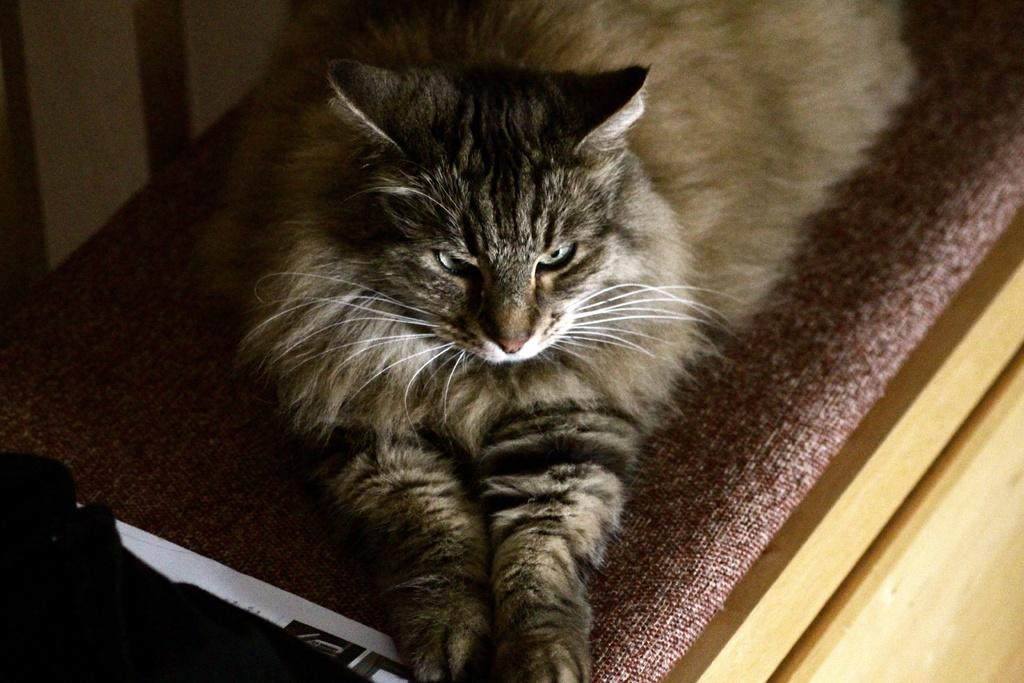What type of animal is in the image? There is a cat in the image. Where is the cat located? The cat is on the bed. What statement does the cat make in the image? Cats do not make statements in images; they are animals and do not have the ability to communicate through language. 